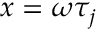<formula> <loc_0><loc_0><loc_500><loc_500>x = \omega \tau _ { j }</formula> 